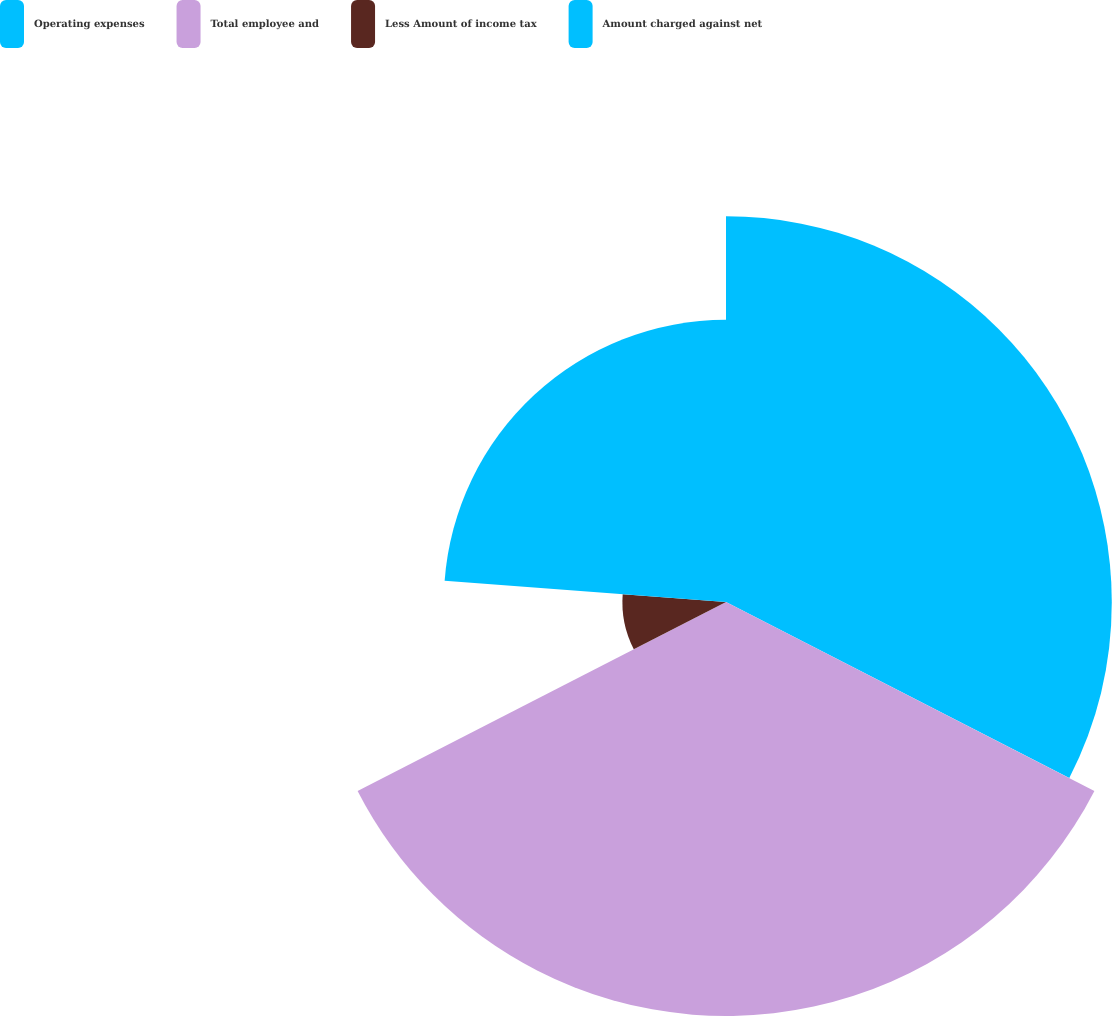<chart> <loc_0><loc_0><loc_500><loc_500><pie_chart><fcel>Operating expenses<fcel>Total employee and<fcel>Less Amount of income tax<fcel>Amount charged against net<nl><fcel>32.54%<fcel>34.92%<fcel>8.74%<fcel>23.8%<nl></chart> 